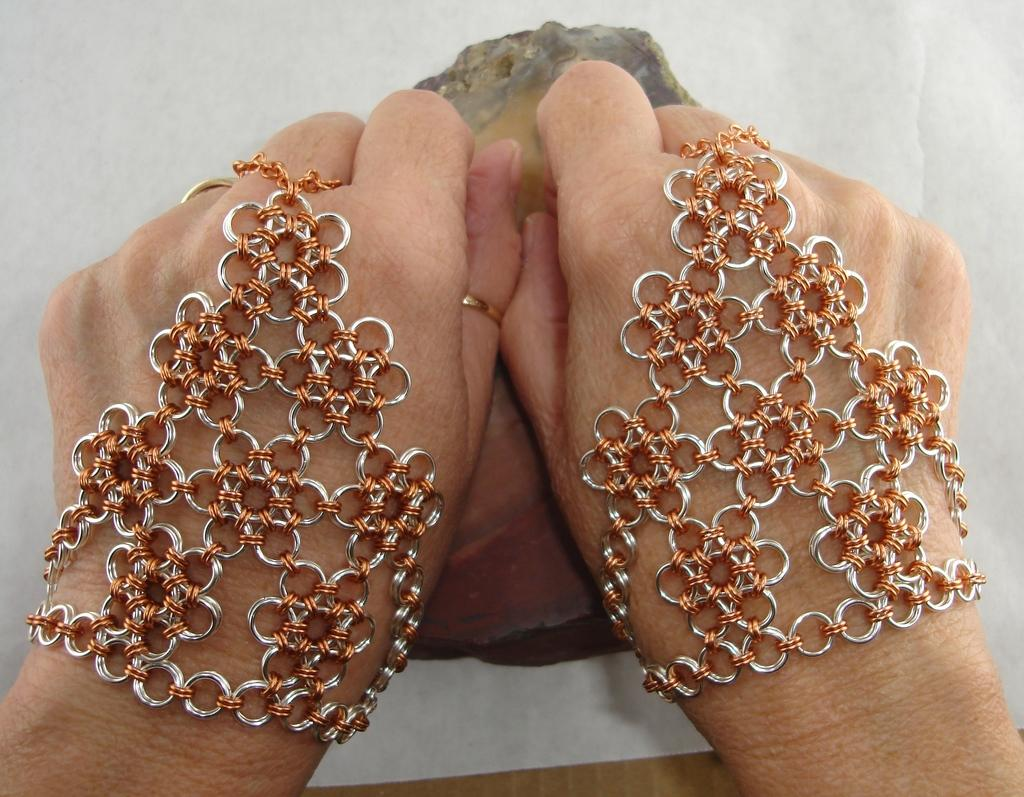What part of a person can be seen in the image? There is a hand of a person in the image. What is the hand wearing? The hand is wearing ring gloves. What route does the grandfather take to visit the men in the image? There is no grandfather or men present in the image, so it is not possible to determine a route. 